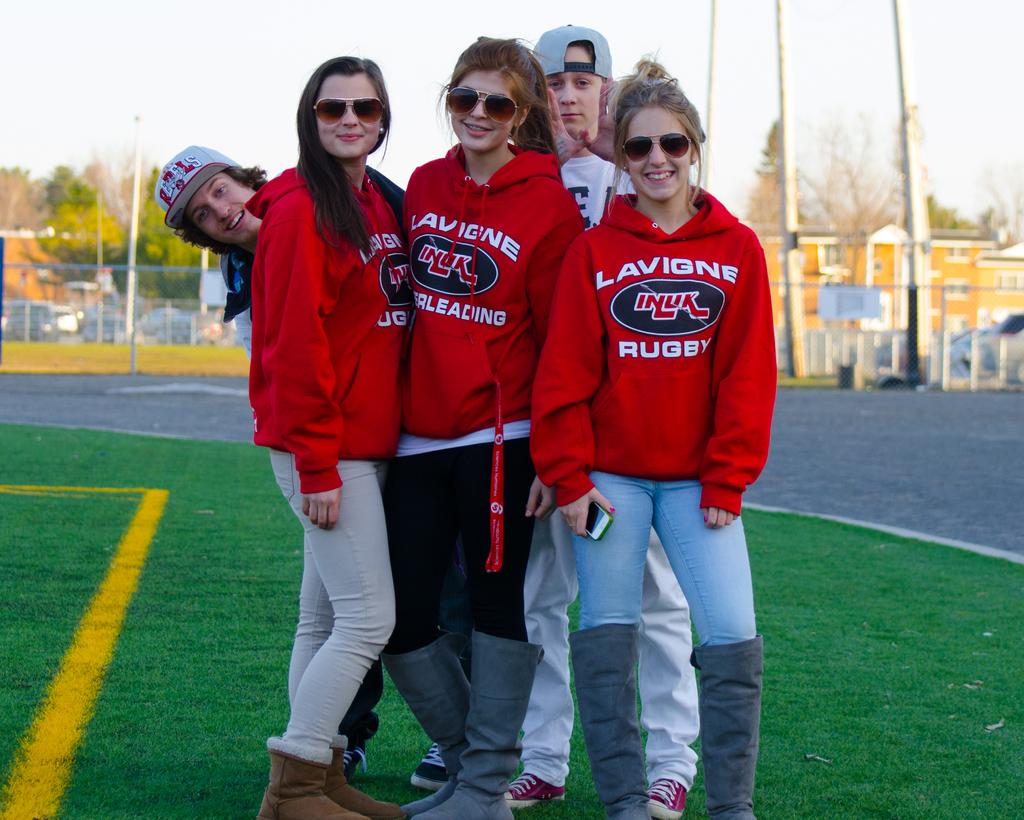What brand of hoodie are they wearing?
Keep it short and to the point. Lavigne rugby. 